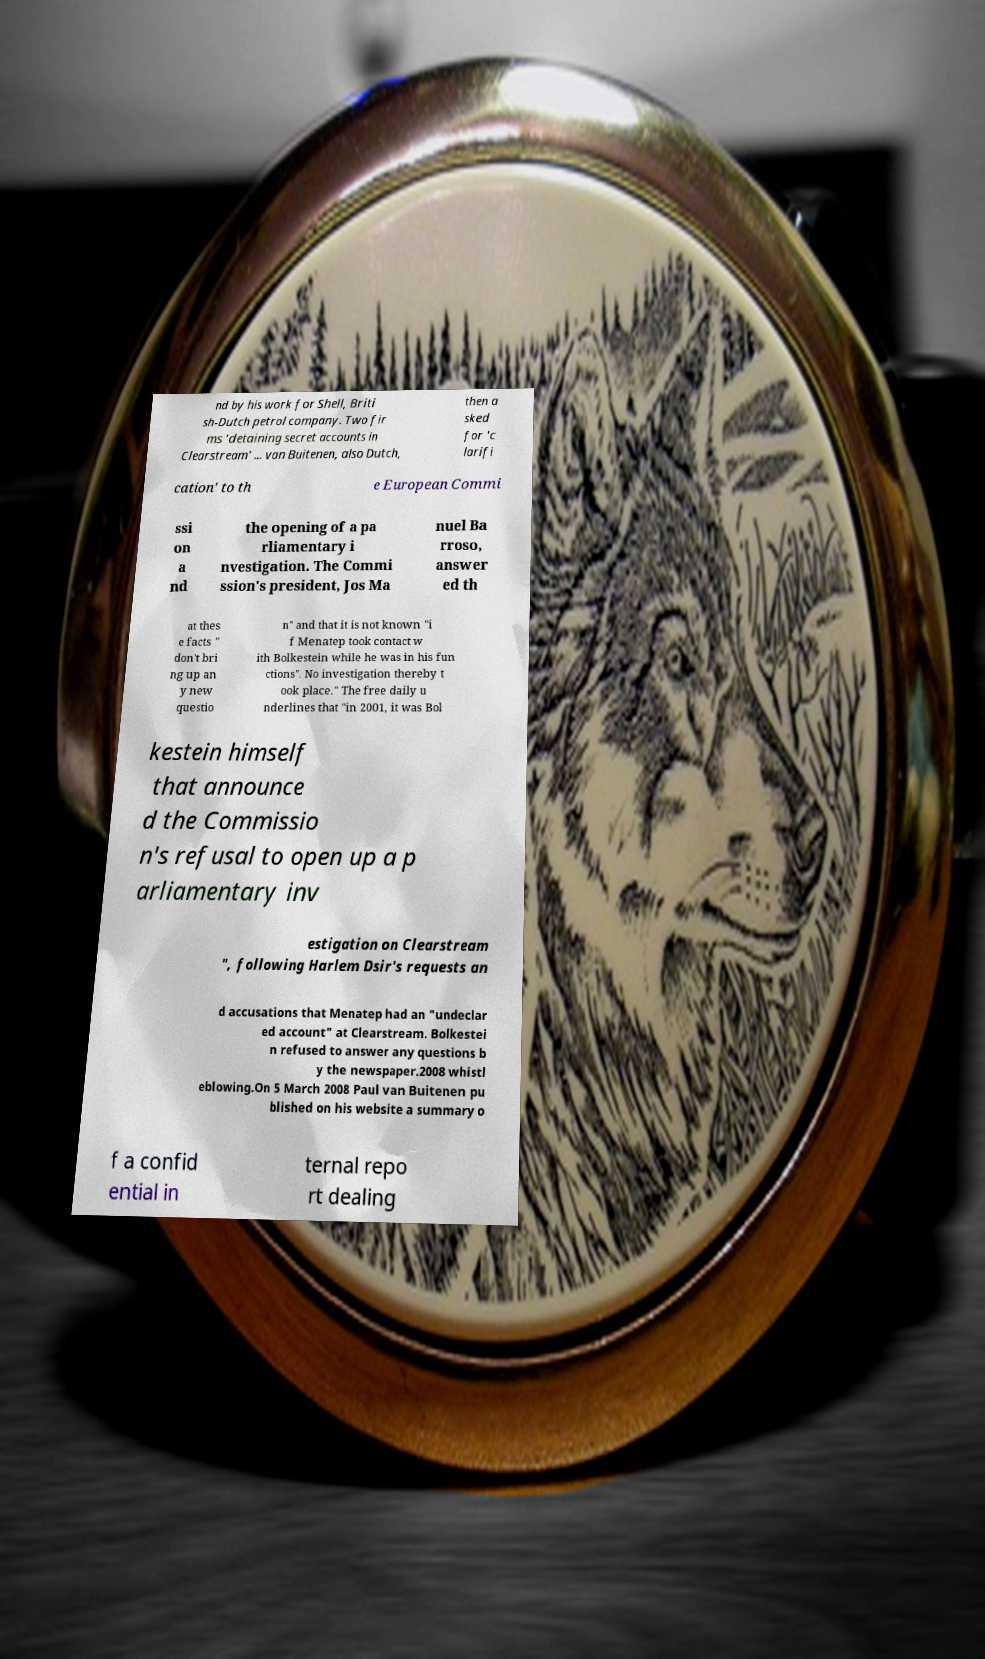Could you extract and type out the text from this image? nd by his work for Shell, Briti sh-Dutch petrol company. Two fir ms 'detaining secret accounts in Clearstream' ... van Buitenen, also Dutch, then a sked for 'c larifi cation' to th e European Commi ssi on a nd the opening of a pa rliamentary i nvestigation. The Commi ssion's president, Jos Ma nuel Ba rroso, answer ed th at thes e facts " don't bri ng up an y new questio n" and that it is not known "i f Menatep took contact w ith Bolkestein while he was in his fun ctions". No investigation thereby t ook place." The free daily u nderlines that "in 2001, it was Bol kestein himself that announce d the Commissio n's refusal to open up a p arliamentary inv estigation on Clearstream ", following Harlem Dsir's requests an d accusations that Menatep had an "undeclar ed account" at Clearstream. Bolkestei n refused to answer any questions b y the newspaper.2008 whistl eblowing.On 5 March 2008 Paul van Buitenen pu blished on his website a summary o f a confid ential in ternal repo rt dealing 